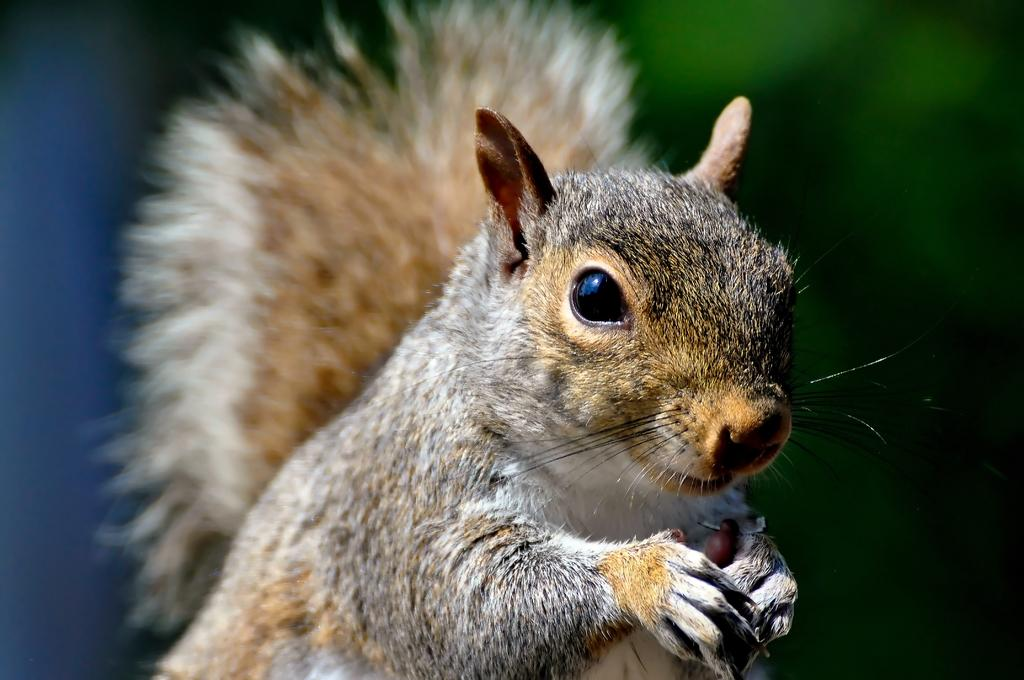What animal is present in the image? There is a squirrel in the image. What is the squirrel doing in the image? The squirrel is holding something. Can you describe the background of the image? The background of the image is blurry. What type of list can be seen in the image? There is no list present in the image; it features a squirrel holding something against a blurry background. 